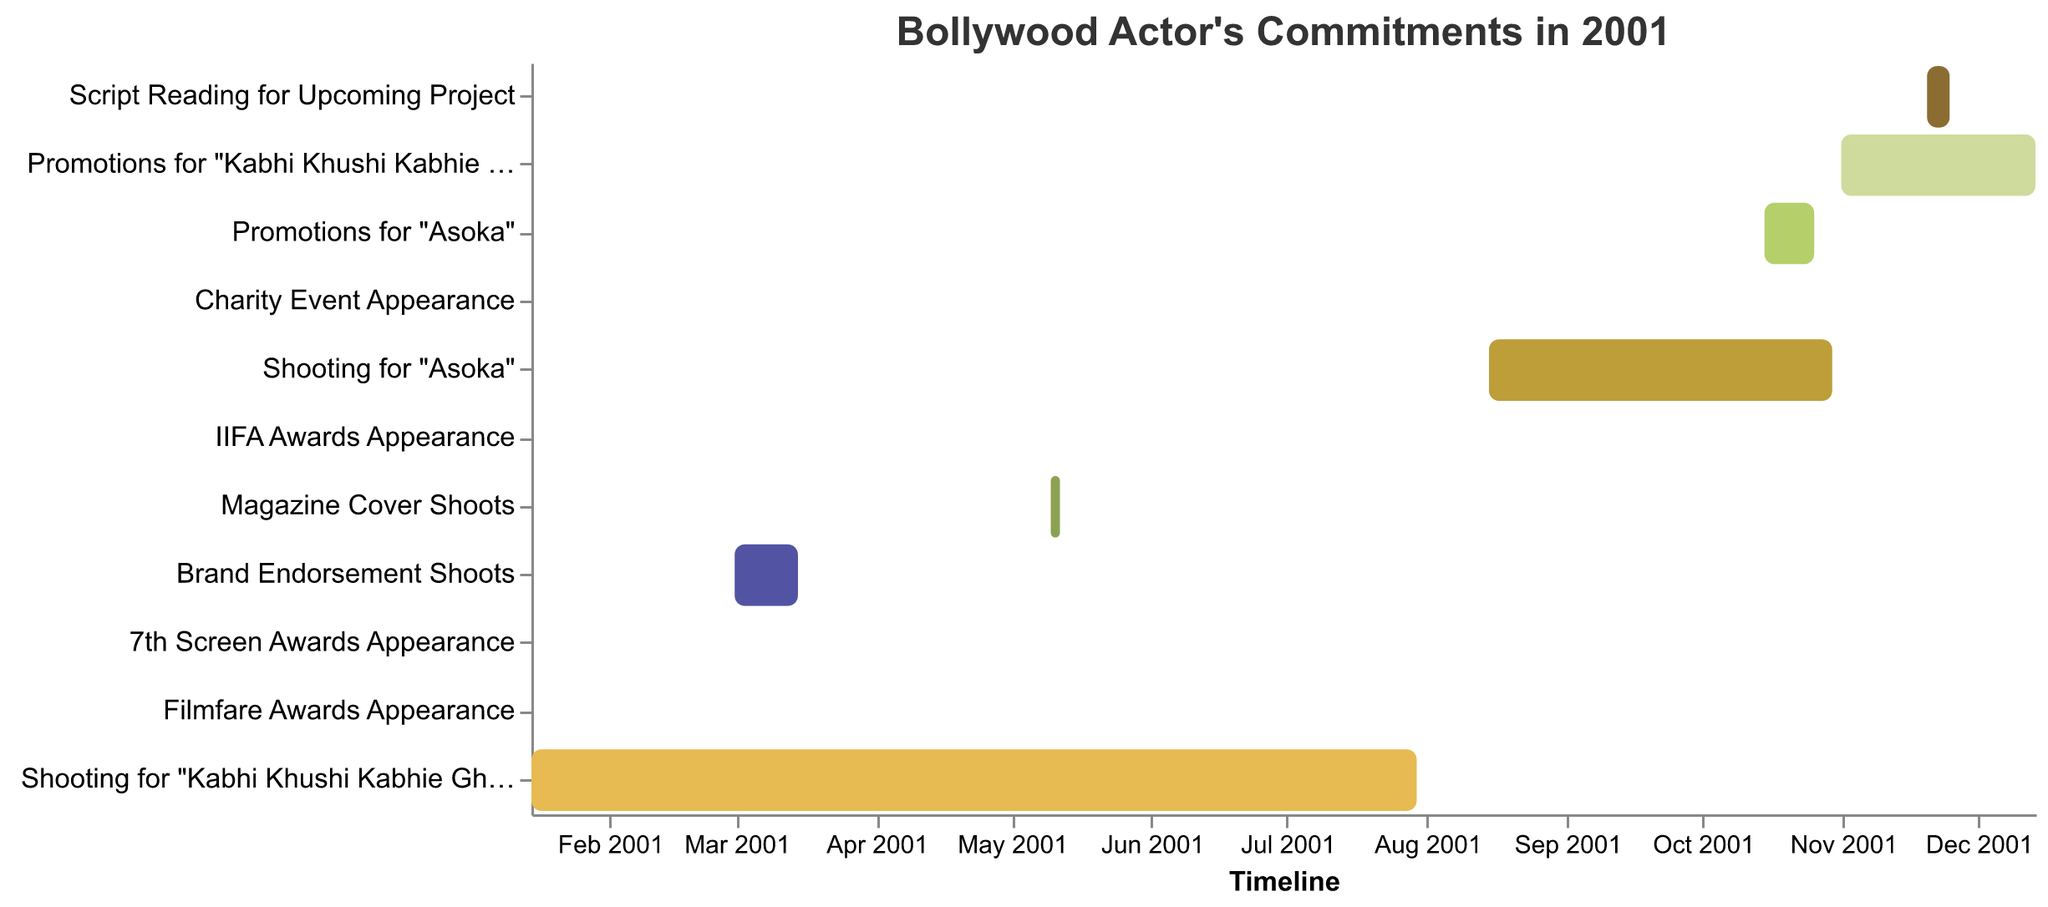What is the title of the Gantt Chart? The title of any plot is the text placed at the top, which summarizes the content or purpose of the plot. In this Gantt Chart, the title is displayed at the top center.
Answer: Bollywood Actor's Commitments in 2001 How many tasks are shown in the Gantt Chart? Count the number of distinct rows or bands that represent different tasks in the plot. Each row corresponds to one task.
Answer: 11 When does the shooting for "Kabhi Khushi Kabhie Gham" start and end? Refer to the specific row for the task "Shooting for 'Kabhi Khushi Kabhie Gham'" and look at the 'Start' and 'End' points on the timeline.
Answer: January 15, 2001 - July 30, 2001 Which event takes place on February 18, 2001, and what other event happens close to this date? Check the exact dates marked in the figure for different tasks and identify events that occur on or around February 18, 2001.
Answer: 7th Screen Awards Appearance; Filmfare Awards Appearance on February 16, 2001 How does the length of time spent on promotions for "Asoka" compare to the promotions for "Kabhi Khushi Kabhie Gham"? Measure the duration by comparing the start and end dates of each promotional period. The length is the difference in days between the start and end dates.
Answer: Promotions for "Asoka" (12 days) are shorter than promotions for "Kabhi Khushi Kabhie Gham" (44 days) What is the total duration of shooting (in days) for both movies "Kabhi Khushi Kabhie Gham" and "Asoka"? Calculate the difference in days for each shoot duration and sum them up. Kabhi Khushi Kabhie Gham: July 30 - January 15. Asoka: October 30 - August 15. Sum the two durations.
Answer: Kabhi Khushi Kabhie Gham: 197 days; Asoka: 76 days; Total: 273 days Which tasks are related to "Kabhi Khushi Kabhie Gham"? Identify all tasks associated with "Kabhi Khushi Kabhie Gham" by reading the different rows for tasks specifically mentioning the movie title.
Answer: Shooting for "Kabhi Khushi Kabhie Gham", Promotions for "Kabhi Khushi Kabhie Gham" What are the start and end dates for the Brand Endorsement Shoots? Locate the row for "Brand Endorsement Shoots" and read the start and end dates directly from the chart.
Answer: March 1, 2001 - March 15, 2001 How many days does the Magazine Cover Shoots task take? Find the start and end dates for "Magazine Cover Shoots" and count the number of days between them.
Answer: 3 days Which task occurs the latest in the year 2001? Look for the task with the latest end date in the timeline, which extends closest to the end of the year.
Answer: Promotions for "Kabhi Khushi Kabhie Gham" 